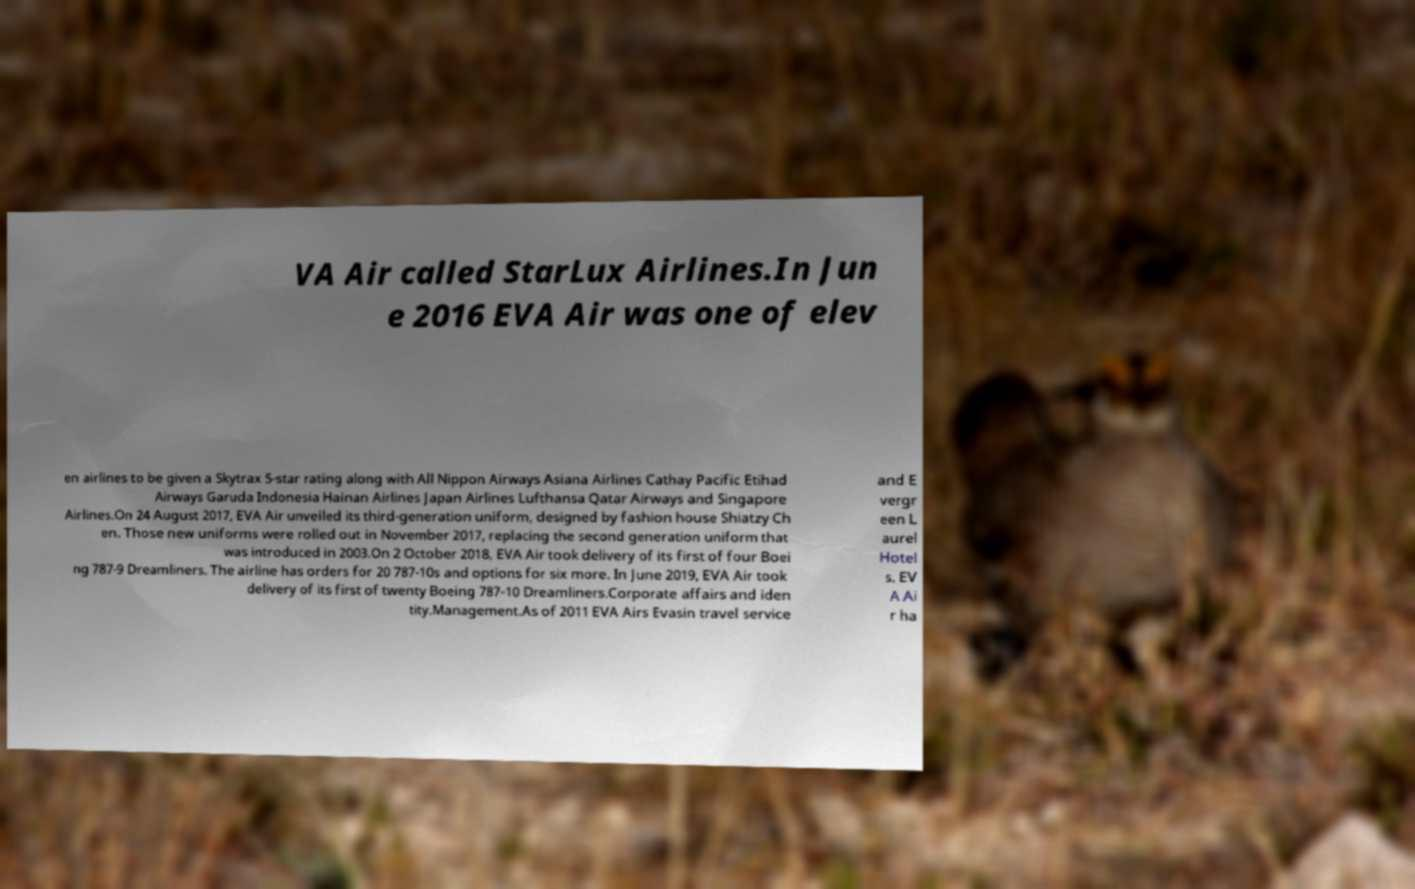There's text embedded in this image that I need extracted. Can you transcribe it verbatim? VA Air called StarLux Airlines.In Jun e 2016 EVA Air was one of elev en airlines to be given a Skytrax 5-star rating along with All Nippon Airways Asiana Airlines Cathay Pacific Etihad Airways Garuda Indonesia Hainan Airlines Japan Airlines Lufthansa Qatar Airways and Singapore Airlines.On 24 August 2017, EVA Air unveiled its third-generation uniform, designed by fashion house Shiatzy Ch en. Those new uniforms were rolled out in November 2017, replacing the second generation uniform that was introduced in 2003.On 2 October 2018, EVA Air took delivery of its first of four Boei ng 787-9 Dreamliners. The airline has orders for 20 787-10s and options for six more. In June 2019, EVA Air took delivery of its first of twenty Boeing 787-10 Dreamliners.Corporate affairs and iden tity.Management.As of 2011 EVA Airs Evasin travel service and E vergr een L aurel Hotel s. EV A Ai r ha 